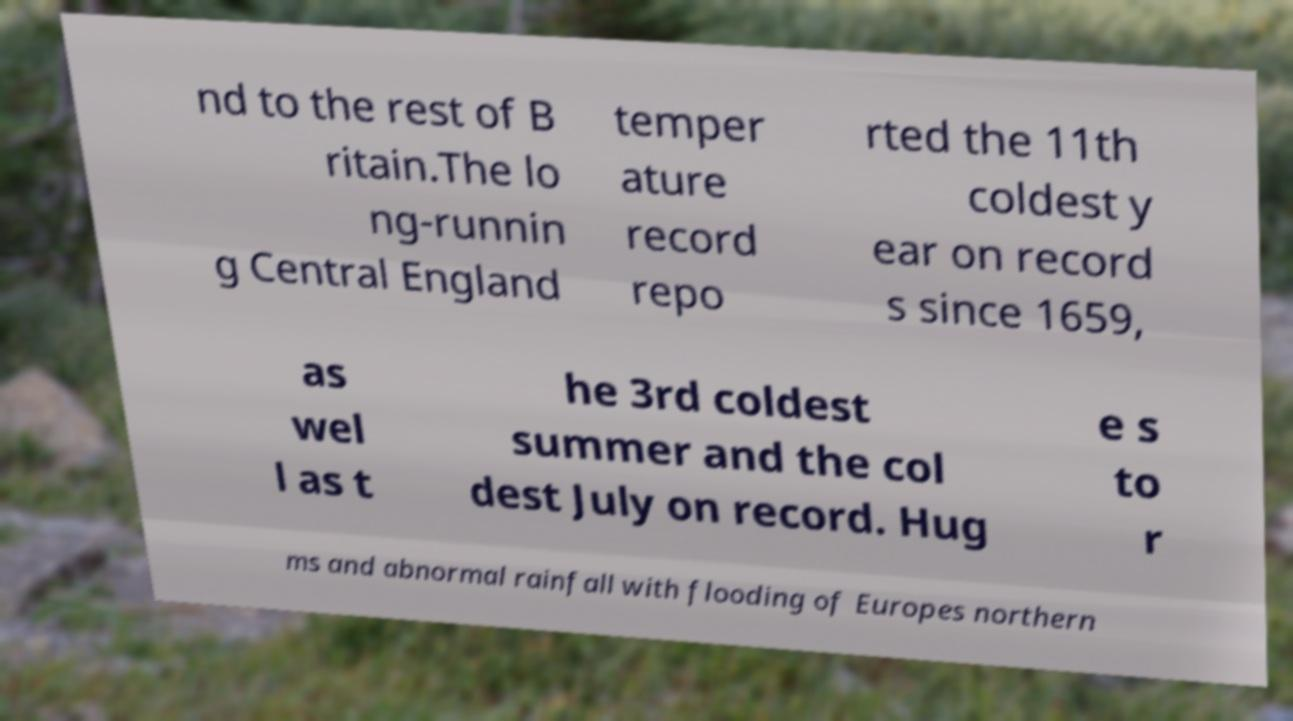There's text embedded in this image that I need extracted. Can you transcribe it verbatim? nd to the rest of B ritain.The lo ng-runnin g Central England temper ature record repo rted the 11th coldest y ear on record s since 1659, as wel l as t he 3rd coldest summer and the col dest July on record. Hug e s to r ms and abnormal rainfall with flooding of Europes northern 